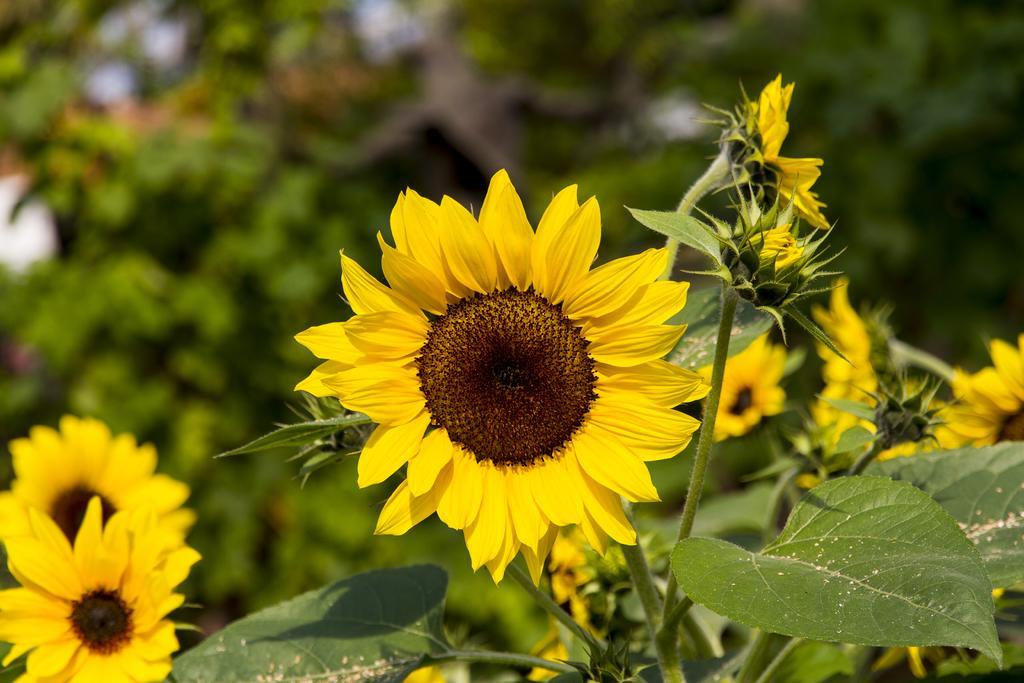In one or two sentences, can you explain what this image depicts? There are plants having yellow color sunflowers and green color leaves. And the background is blurred. 